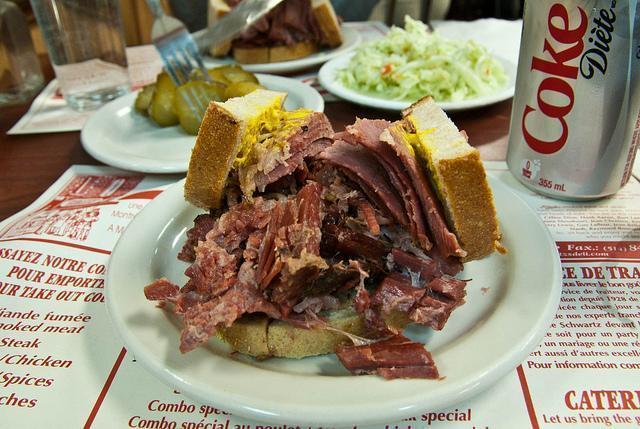How many cups are in the photo?
Give a very brief answer. 2. How many sandwiches are in the photo?
Give a very brief answer. 2. 